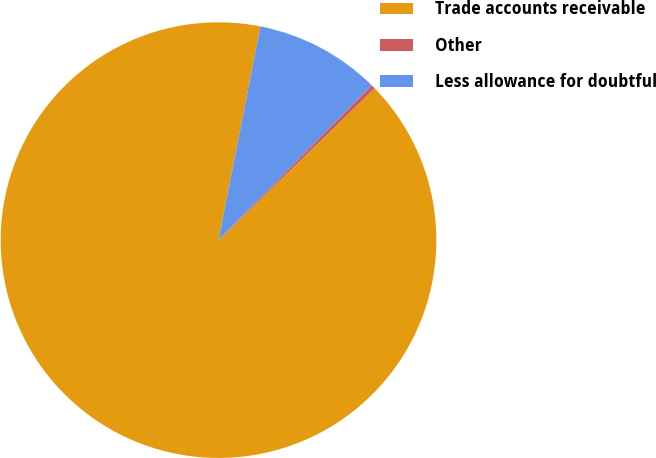<chart> <loc_0><loc_0><loc_500><loc_500><pie_chart><fcel>Trade accounts receivable<fcel>Other<fcel>Less allowance for doubtful<nl><fcel>90.35%<fcel>0.32%<fcel>9.33%<nl></chart> 